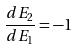<formula> <loc_0><loc_0><loc_500><loc_500>\frac { d E _ { 2 } } { d E _ { 1 } } = - 1</formula> 